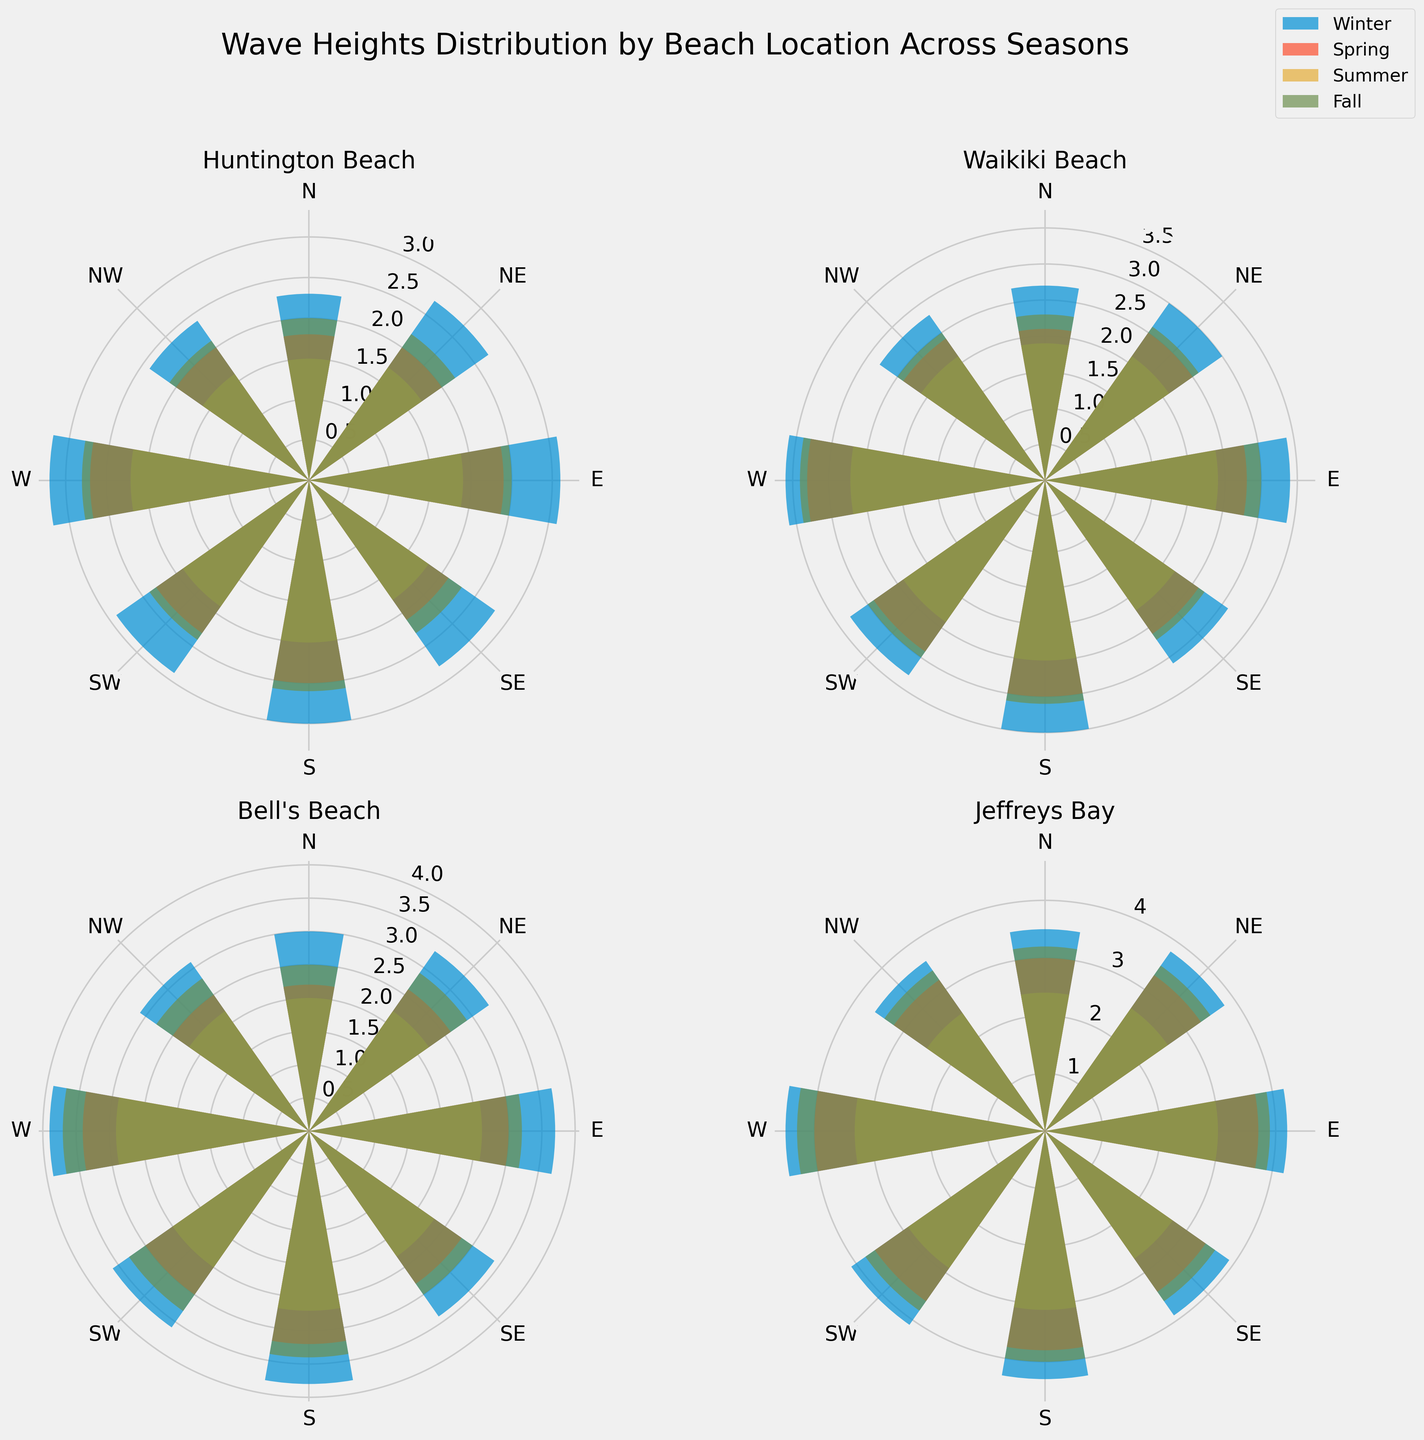Which beach location has the highest wave heights recorded during Winter? To answer this, observe the bars showing wave heights for the winter season across all four subplots. Identify the beach that has the tallest bars.
Answer: Jeffreys Bay In which season does Huntington Beach experience the lowest average wave height? Compare the average heights of the bars for each season in the Huntington Beach subplot. Look for the season with the smallest bar heights on average.
Answer: Summer Which direction tends to have the highest wave heights at Bell's Beach in Fall? Examine the Bell's Beach subplot for the Fall season. Look for the tallest bar to determine the direction with the highest wave height.
Answer: W Compare the average wave height in Winter between Waikiki Beach and Bell's Beach. Which one is higher? Calculate the average wave height for each beach in winter by summing up the heights of all bars and dividing by the number of bars (8). Compare these averages to determine which is higher.
Answer: Bell's Beach Which beach location has the most consistent wave height distribution across all seasons? Assess the subplots to see which location has bars that are relatively equal in height throughout all seasons, indicating consistent wave heights.
Answer: Huntington Beach What is the difference in the average wave height between Spring and Summer at Jeffreys Bay? Calculate the average wave height for Spring and Summer separately by summing up the heights of the bars and dividing by 8. Subtract the Summer average from the Spring average to get the difference.
Answer: 0.7 Which season at Waikiki Beach has the tallest wave height from the Northern direction? Look at the Waikiki Beach subplot and identify the bar labeled 'N' across the seasons. Identify the season with the tallest 'N' bar.
Answer: Winter In Fall, which location records a higher wave height in the Southern direction, Huntington Beach or Jeffreys Bay? Compare the bar heights labeled 'S' in Fall for both Huntington Beach and Jeffreys Bay subplots. Determine which is taller.
Answer: Jeffreys Bay What is the total wave height of all directions combined at Bell's Beach in Spring? Sum up the heights of all the bars for Bell's Beach subplot in the Spring season.
Answer: 23.7 Compare the range of wave heights (difference between maximum and minimum wave heights) in Summer at both Huntington Beach and Waikiki Beach. Identify the maximum and minimum bars in the Summer season for both Huntington Beach and Waikiki Beach subplots. Subtract the minimum height from the maximum height for each beach and compare the results.
Answer: Waikiki Beach has a larger range 